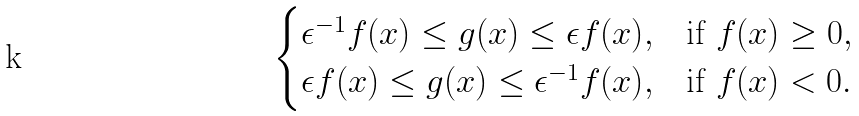<formula> <loc_0><loc_0><loc_500><loc_500>\begin{cases} \epsilon ^ { - 1 } f ( x ) \leq g ( x ) \leq \epsilon f ( x ) , & \text {if $f(x)\geq 0$} , \\ \epsilon f ( x ) \leq g ( x ) \leq \epsilon ^ { - 1 } f ( x ) , & \text {if $f(x) < 0$} . \end{cases}</formula> 